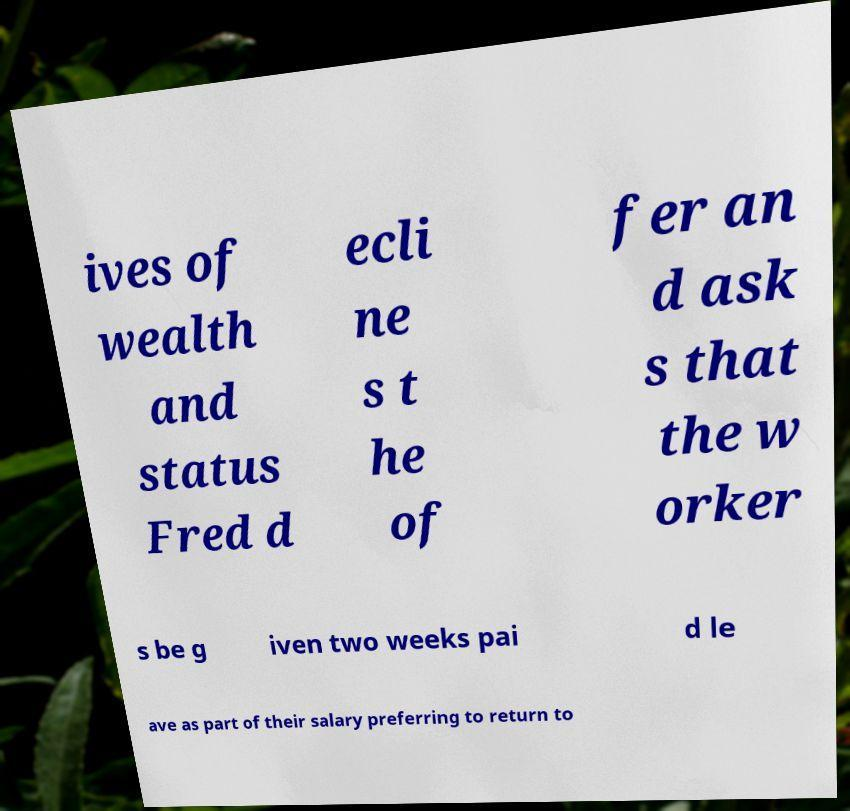Please read and relay the text visible in this image. What does it say? ives of wealth and status Fred d ecli ne s t he of fer an d ask s that the w orker s be g iven two weeks pai d le ave as part of their salary preferring to return to 